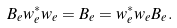Convert formula to latex. <formula><loc_0><loc_0><loc_500><loc_500>B _ { e } w _ { e } ^ { * } w _ { e } = B _ { e } = w _ { e } ^ { * } w _ { e } B _ { e } .</formula> 